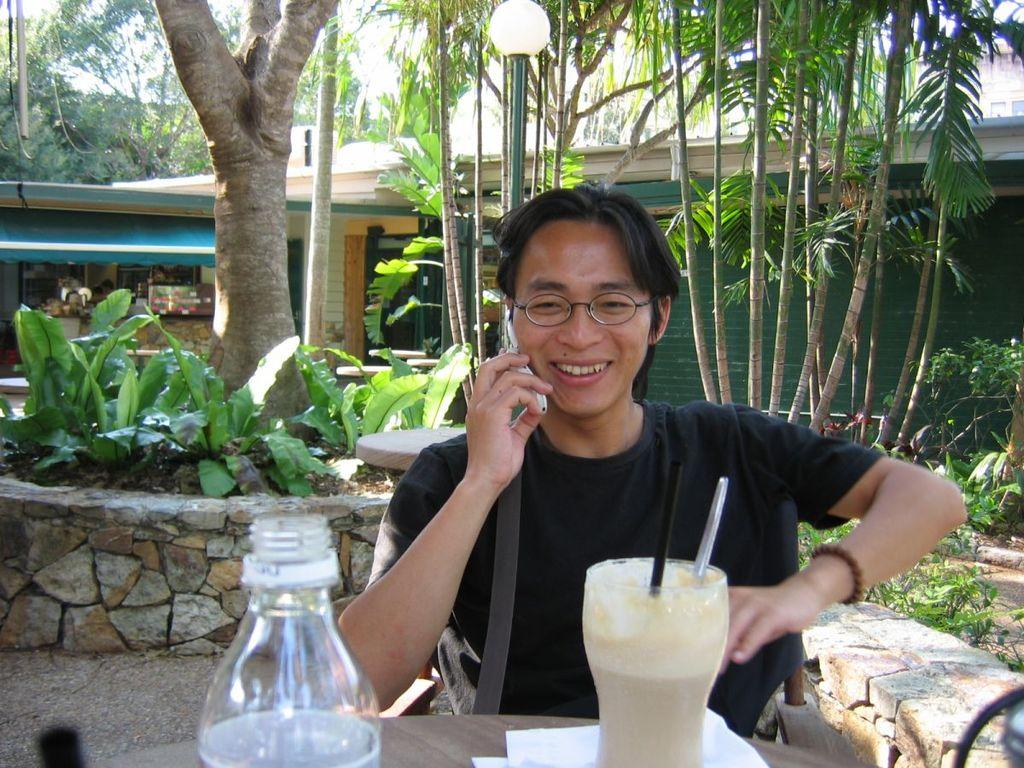What color is the shirt worn by the person in the image? The person is wearing a black shirt. What is the person doing in the image? The person is speaking on the phone. What beverages are in front of the person? There is a milkshake and a water bottle in front of the person. What can be seen in the background of the image? There are trees and a green building in the background of the image. What type of owl can be seen perched on the person's finger in the image? There is no owl present in the image, and the person's finger is not visible. 